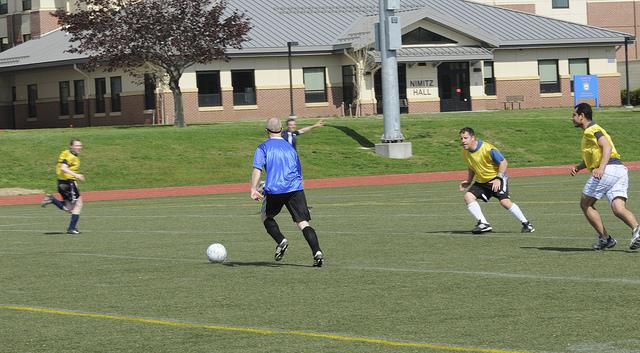Are the men enjoying the game?
Short answer required. Yes. Are they wearing team uniforms?
Write a very short answer. Yes. Are the players running toward's the ball?
Keep it brief. Yes. Are these men all on one team?
Be succinct. No. Are these men playing on an actual field?
Write a very short answer. Yes. What is the color of the soccer balls?
Short answer required. White. What is this sport?
Quick response, please. Soccer. 